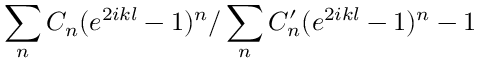<formula> <loc_0><loc_0><loc_500><loc_500>\sum _ { n } C _ { n } ( e ^ { 2 i k l } - 1 ) ^ { n } / \sum _ { n } C _ { n } ^ { \prime } ( e ^ { 2 i k l } - 1 ) ^ { n } - 1</formula> 